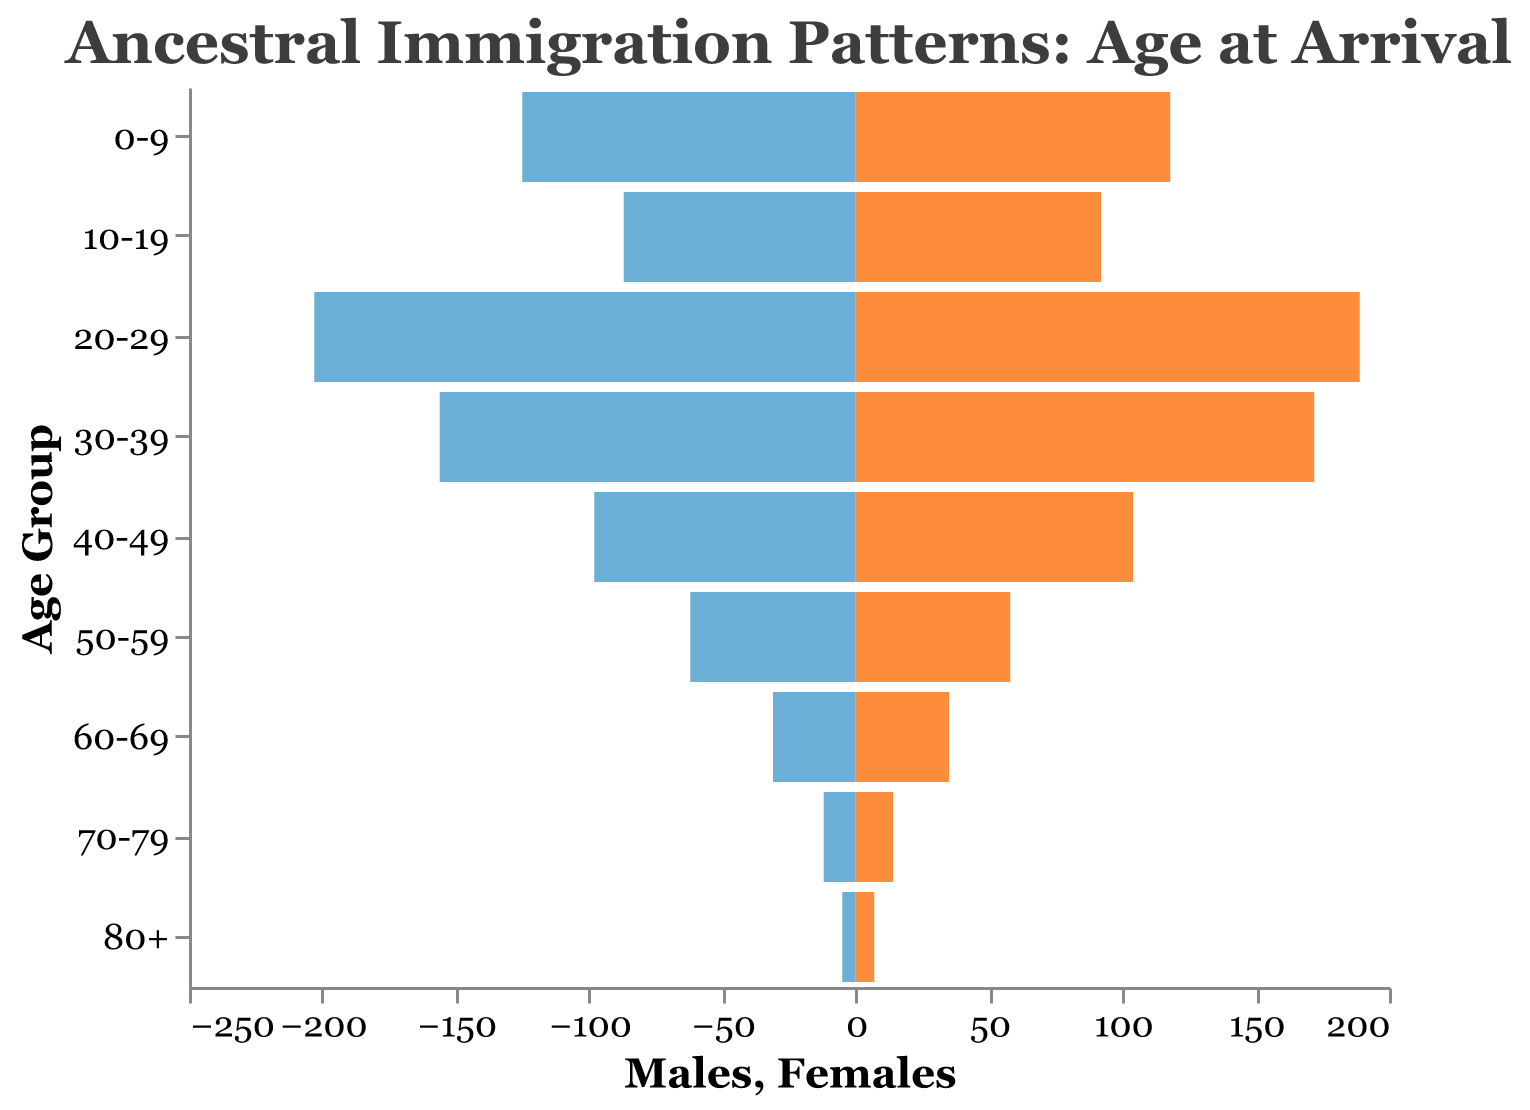What is the title of the figure? The title of the figure is located at the top and it summarizes the subject of the visualization.
Answer: Ancestral Immigration Patterns: Age at Arrival How many age groups are displayed in the figure? Count the number of unique age groups listed on the y-axis.
Answer: 9 Which age group has the highest number of males? Identify the bar on the left side (Males) with the greatest length.
Answer: 20-29 Are there more females than males in the 30-39 age group? Compare the length of the bars for males and females within the 30-39 age group.
Answer: Yes Which age group has the smallest number of females? Locate the shortest bar on the right side (Females).
Answer: 80+ What is the difference in the number of males and females in the 50-59 age group? Subtract the number of females from the number of males in the 50-59 age group: 62 (Males) - 58 (Females) = 4.
Answer: 4 In which age group are the male and female numbers most equal? Find the age group where the difference between the number of males and females is the smallest. This requires examining the bars for each age group. The 0-9 age group has 125 males and 118 females, leading to a difference of 7, which is the smallest difference observed.
Answer: 0-9 What is the total number of people aged 70+ in the figure? Sum the number of males and females for the age groups 70-79 and 80+: (12+14) + (5+7). First calculate for 70-79: 12 males + 14 females = 26. Then for 80+: 5 males + 7 females = 12. Finally, add them together: 26 + 12 = 38.
Answer: 38 Which age group has the second highest total number of immigrants? Calculate the total number of immigrants for each age group and identify the one with the second highest value. The 20-29 age group has 392 (203+189), 30-39 has 328 (156+172), and others are lower; 30-39 is next highest after 20-29.
Answer: 30-39 